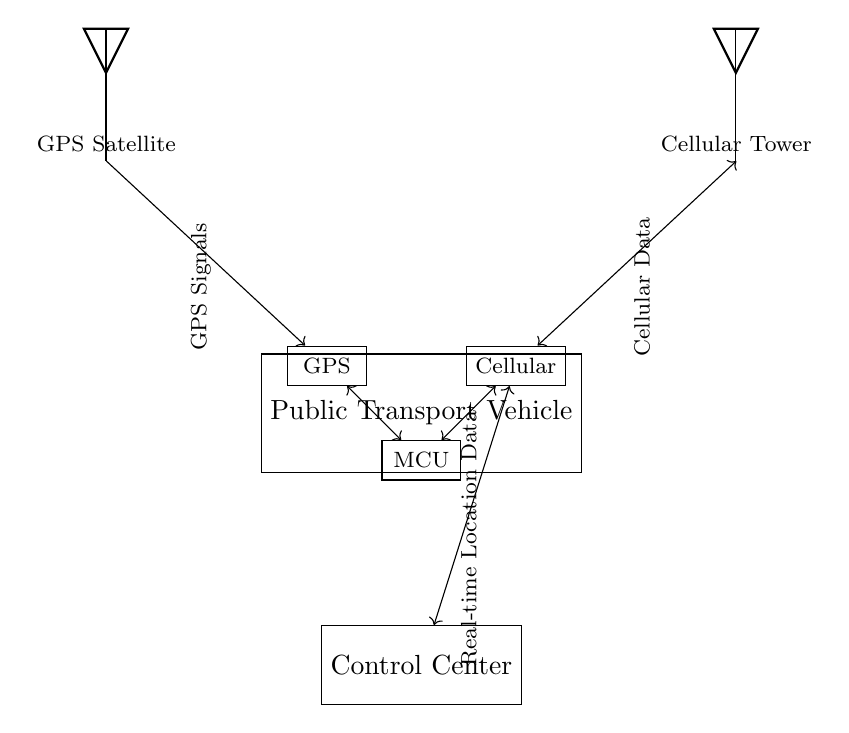What is the main communication technology used in this system? The main communication technology used in this system is Cellular, as shown by the component labeled "Cellular" and its connection to the control center.
Answer: Cellular How many components are involved in the public transport vehicle's communication system? The components involved are the GPS receiver, cellular transceiver, and microcontroller. There are three key components highlighted in the circuit diagram.
Answer: Three What data type does the GPS satellite transmit? The GPS satellite transmits GPS Signals, indicated by the label next to the GPS symbol in the diagram, directing to the GPS receiver.
Answer: GPS Signals How is real-time location data transferred to the control center? Real-time location data is transferred via Cellular Data, as depicted by the bidirectional arrow connecting the cellular transceiver and the control center.
Answer: Cellular Data What role does the microcontroller play in this system? The microcontroller (MCU) integrates data from both the GPS receiver and cellular transceiver, facilitating the transmission of location data to the control center, which is illustrated by its connections to these components.
Answer: Integration Which component receives the GPS signals? The GPS receiver receives the GPS signals, as indicated by the connection line from the GPS satellite leading to the GPS receiver.
Answer: GPS Receiver What is the purpose of the cellular transceiver in this circuit? The cellular transceiver's purpose is to send and receive cellular data, facilitating communication between the public transport vehicle and the control center, as evidenced by its connections to both the control center and the microcontroller.
Answer: Send and receive cellular data 